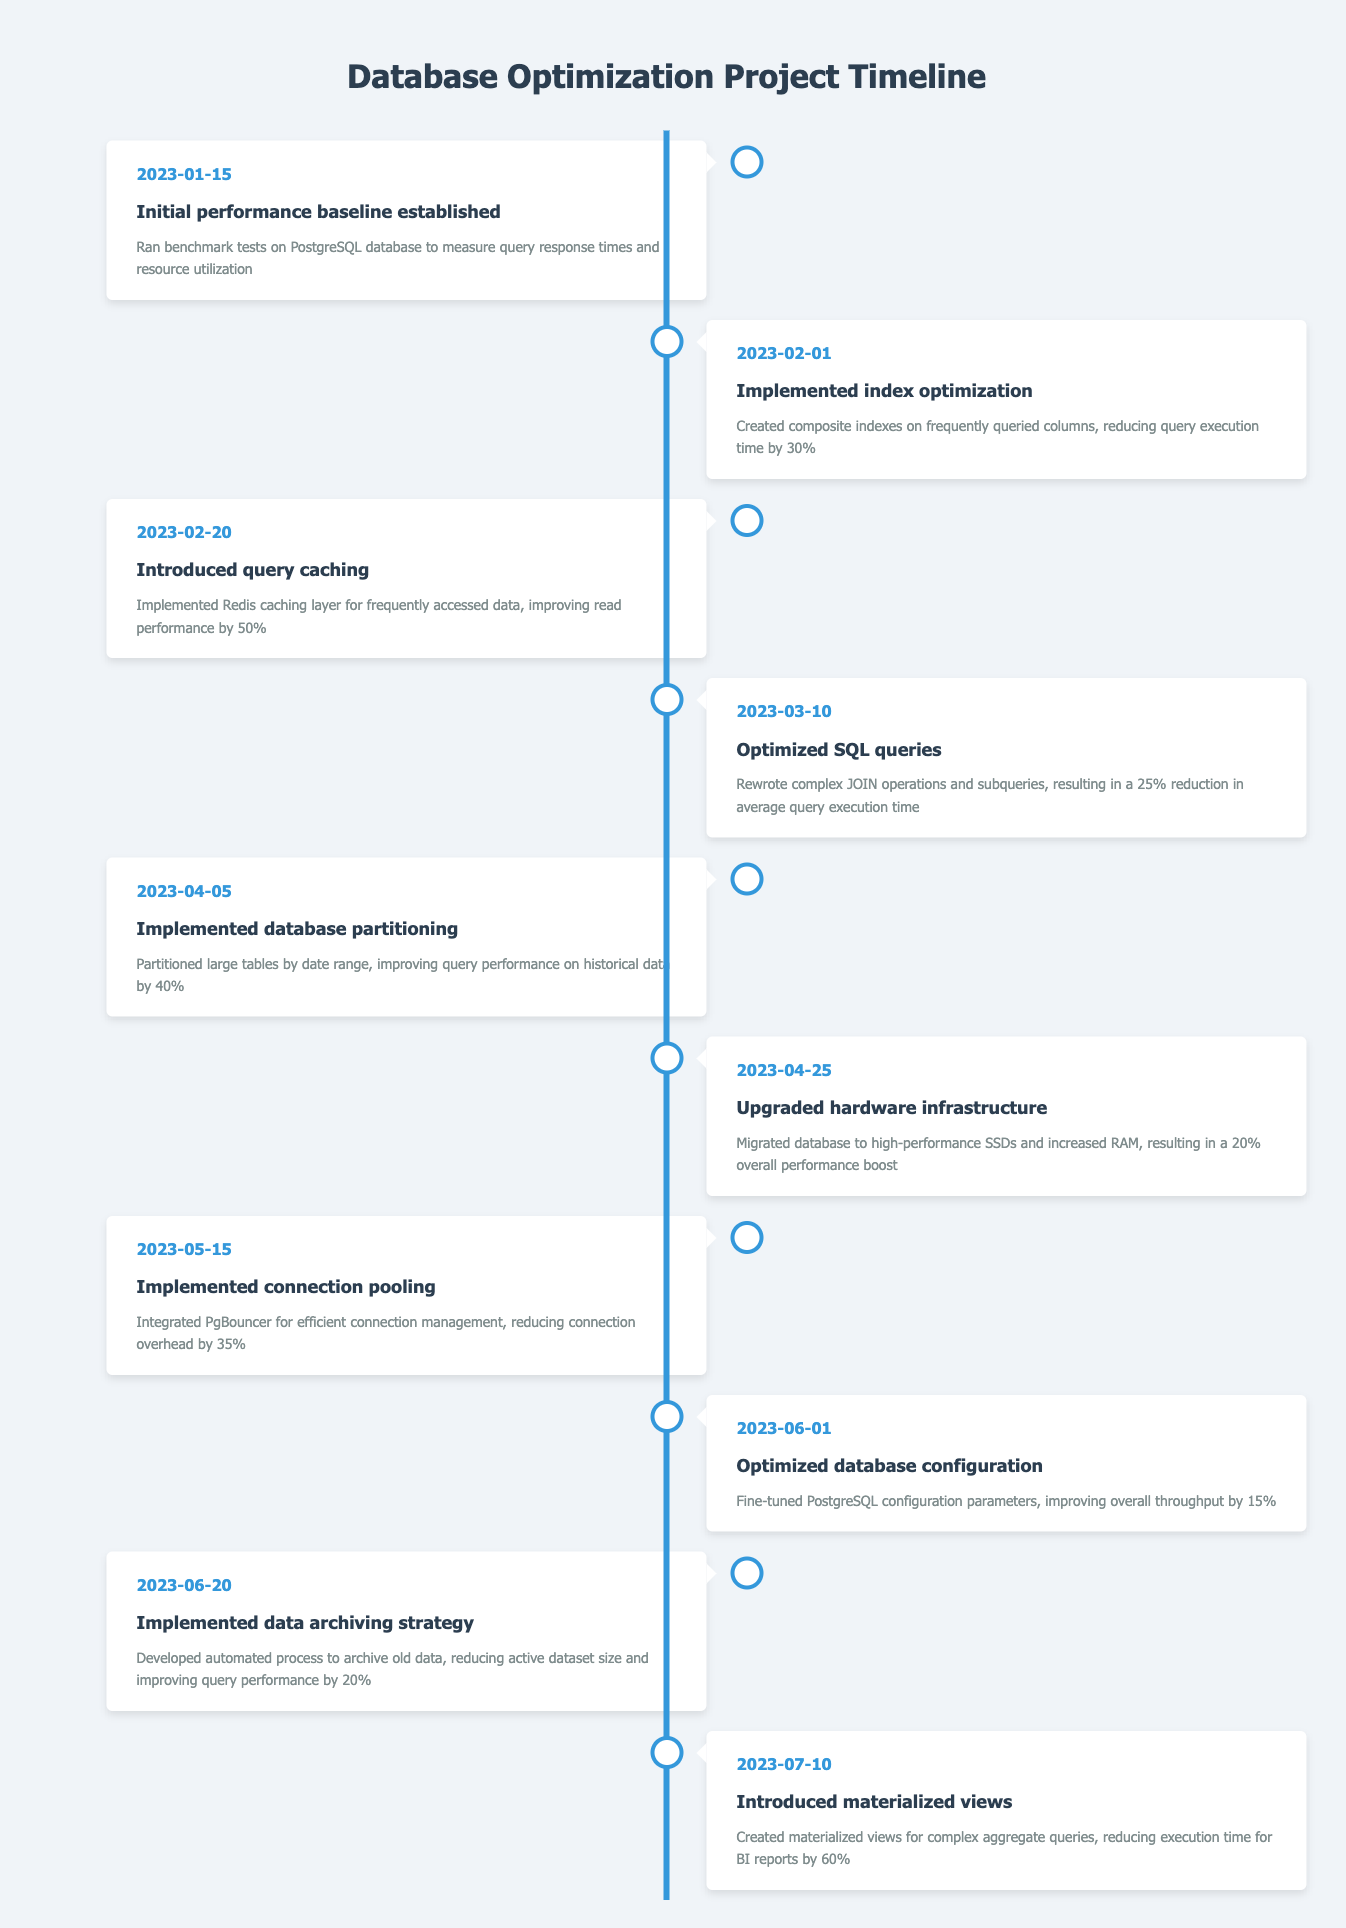What was the date when the initial performance baseline was established? According to the timeline, the initial performance baseline was established on January 15, 2023.
Answer: January 15, 2023 How much did query execution time decrease after implementing index optimization? The implementation of index optimization on February 1, 2023, resulted in a 30% reduction in query execution time.
Answer: 30% What event occurred between February and March 2023? Between February 1 and March 10, 2023, index optimization was implemented and SQL queries were optimized.
Answer: Index optimization and SQL query optimization True or False: Database partitioning improved query performance on historical data by 40%. Yes, the event on April 5, 2023, states that database partitioning improved query performance on historical data by 40%.
Answer: True What is the total performance improvement achieved through the combination of implementing connection pooling and optimizing database configuration? Connection pooling reduced connection overhead by 35%, and optimizing database configuration improved throughput by 15%. The total improvement is 35% + 15% = 50%.
Answer: 50% Which event recorded the highest performance improvement percentage and what was that percentage? The creation of materialized views on July 10, 2023, recorded the highest performance improvement, with a reduction in execution time for BI reports by 60%.
Answer: 60% What were the two main performance improvements implemented on June 2023? In June 2023, database configuration optimization and a data archiving strategy were implemented. The former improved throughput by 15%, and the latter improved query performance by 20%.
Answer: Optimizing database configuration and implementing data archiving strategy List all the improvements made to the database in chronological order up to May 15, 2023. The improvements made until May 15, 2023 are: 1. Initial performance baseline established, 2. Implemented index optimization, 3. Introduced query caching, 4. Optimized SQL queries, 5. Implemented database partitioning, 6. Upgraded hardware infrastructure, 7. Implemented connection pooling.
Answer: Initial performance baseline, index optimization, query caching, SQL query optimization, database partitioning, hardware upgrade, connection pooling How many events improved query performance after June 2023? After June 2023, one event that improved query performance was the introduction of materialized views on July 10, 2023, which reduced execution time for BI reports by 60%. Therefore, there was 1 event.
Answer: 1 